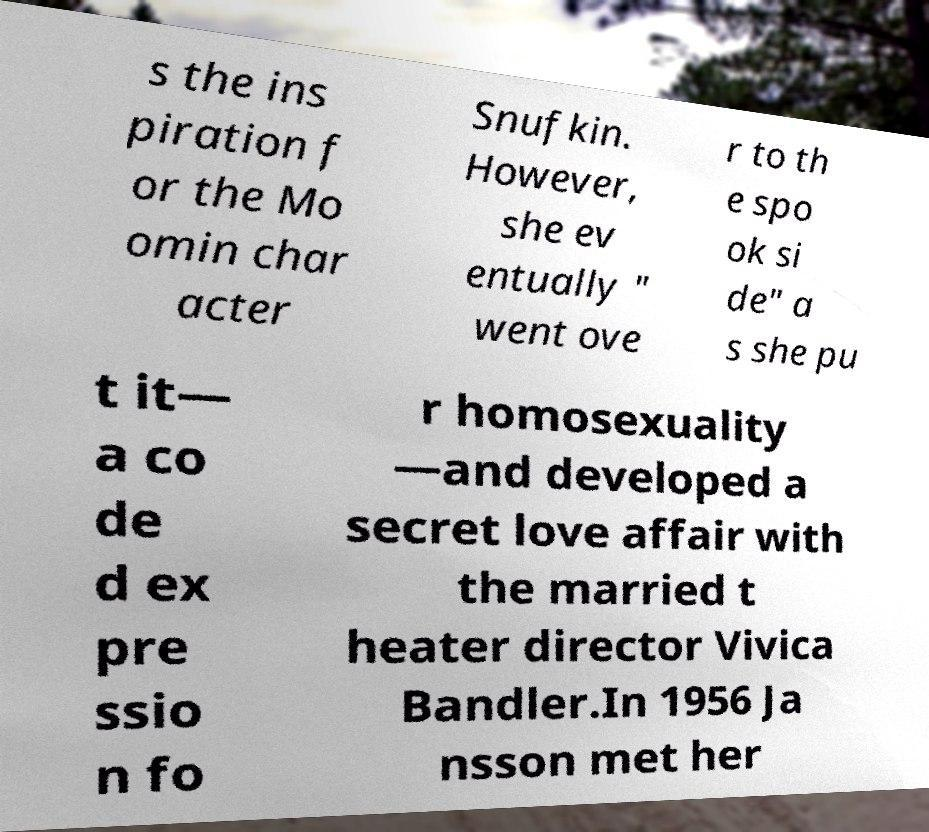Could you assist in decoding the text presented in this image and type it out clearly? s the ins piration f or the Mo omin char acter Snufkin. However, she ev entually " went ove r to th e spo ok si de" a s she pu t it— a co de d ex pre ssio n fo r homosexuality —and developed a secret love affair with the married t heater director Vivica Bandler.In 1956 Ja nsson met her 